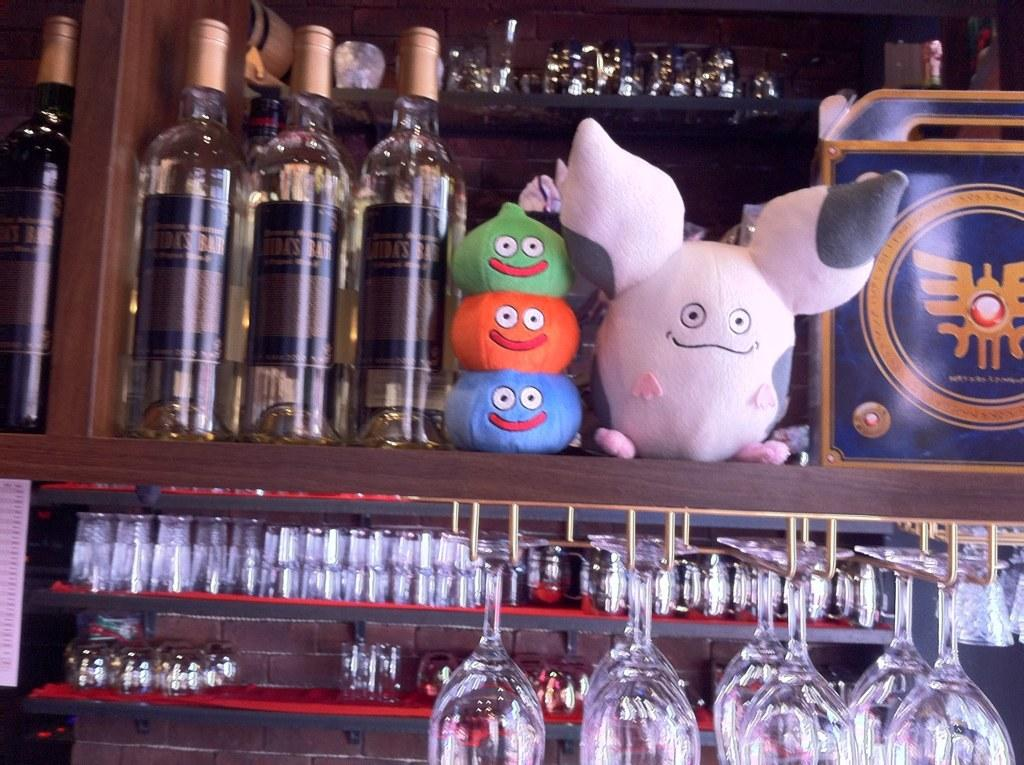What type of objects can be seen in the image? There are bottles, glasses, and soft toys in the image. Can you describe the bottles in the image? The bottles are visible in the image, but their contents or specific characteristics are not mentioned in the provided facts. What are the glasses used for in the image? The purpose of the glasses in the image is not specified in the provided facts. What type of soft toys are present in the image? The type of soft toys in the image is not mentioned in the provided facts. What type of jam is being spread on the pest in the image? There is no jam or pest present in the image; the provided facts only mention bottles, glasses, and soft toys. 